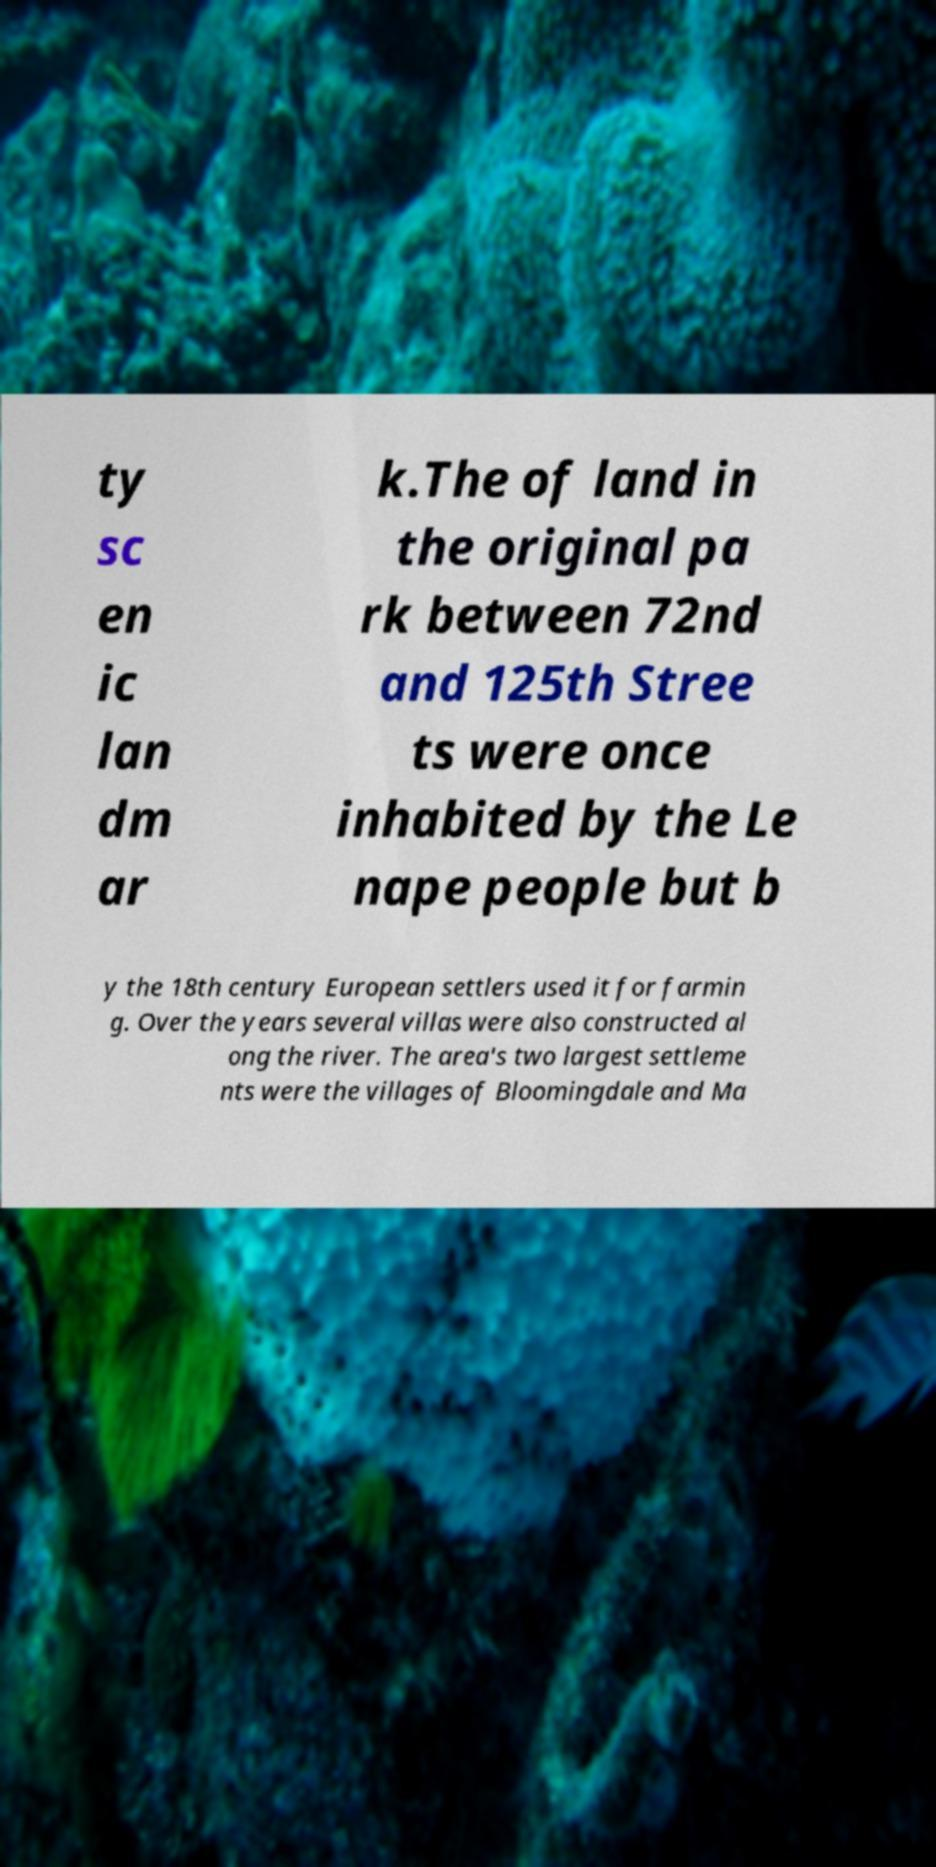Can you accurately transcribe the text from the provided image for me? ty sc en ic lan dm ar k.The of land in the original pa rk between 72nd and 125th Stree ts were once inhabited by the Le nape people but b y the 18th century European settlers used it for farmin g. Over the years several villas were also constructed al ong the river. The area's two largest settleme nts were the villages of Bloomingdale and Ma 